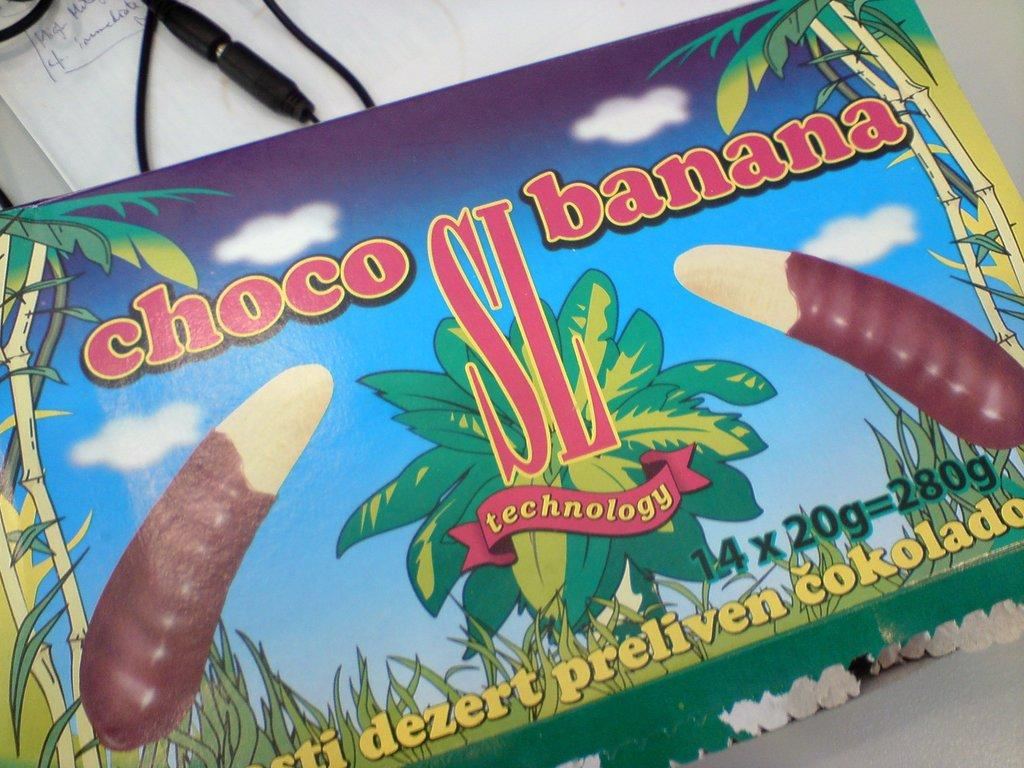What is the main object in the image? There is a card with text and figures in the image. What else can be seen in the image besides the card? There is a cable visible in the image. Where is the text located in the image? There is text on a white surface in the image. Can you see a ghost interacting with the card in the image? No, there is no ghost present in the image. 